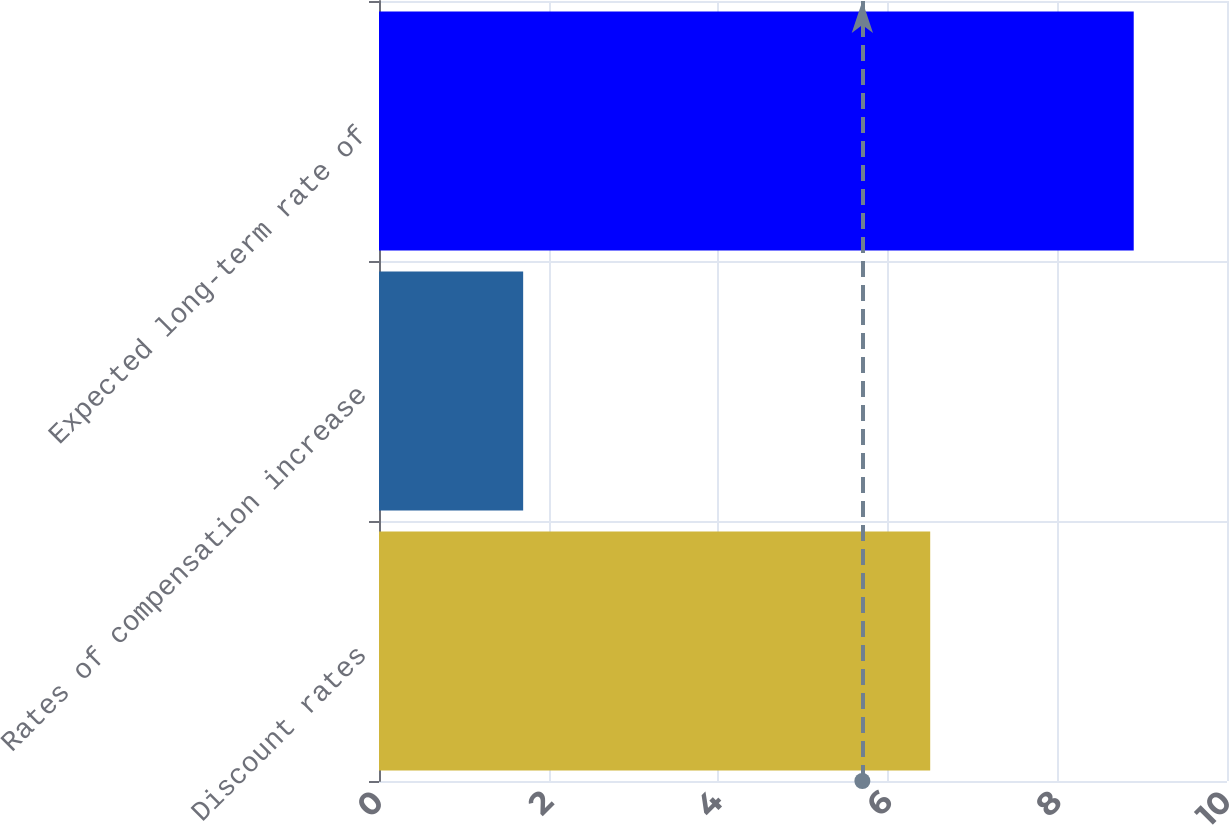<chart> <loc_0><loc_0><loc_500><loc_500><bar_chart><fcel>Discount rates<fcel>Rates of compensation increase<fcel>Expected long-term rate of<nl><fcel>6.5<fcel>1.7<fcel>8.9<nl></chart> 